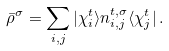<formula> <loc_0><loc_0><loc_500><loc_500>\bar { \rho } ^ { \sigma } = \sum _ { i , j } | \chi ^ { t } _ { i } \rangle n ^ { t , \sigma } _ { i , j } \langle \chi ^ { t } _ { j } | \, .</formula> 